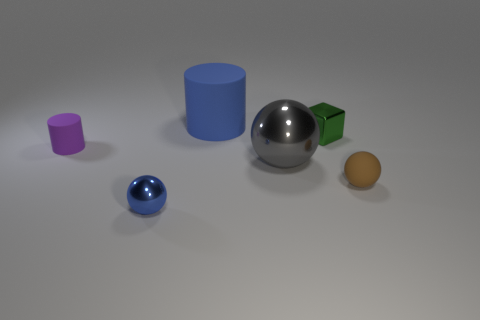Are there any other things that are the same size as the green block?
Offer a very short reply. Yes. The small metallic thing behind the tiny ball in front of the rubber ball is what shape?
Offer a terse response. Cube. Are there any other tiny green shiny objects that have the same shape as the green metal thing?
Your answer should be compact. No. There is a large cylinder; is its color the same as the tiny rubber thing on the right side of the big blue thing?
Your response must be concise. No. There is a metal sphere that is the same color as the large rubber thing; what is its size?
Your answer should be very brief. Small. Are there any green blocks that have the same size as the green thing?
Provide a succinct answer. No. Does the tiny cylinder have the same material as the tiny object in front of the brown sphere?
Give a very brief answer. No. Are there more tiny blue shiny spheres than blue things?
Keep it short and to the point. No. How many spheres are brown rubber things or small green objects?
Ensure brevity in your answer.  1. The metal block is what color?
Keep it short and to the point. Green. 